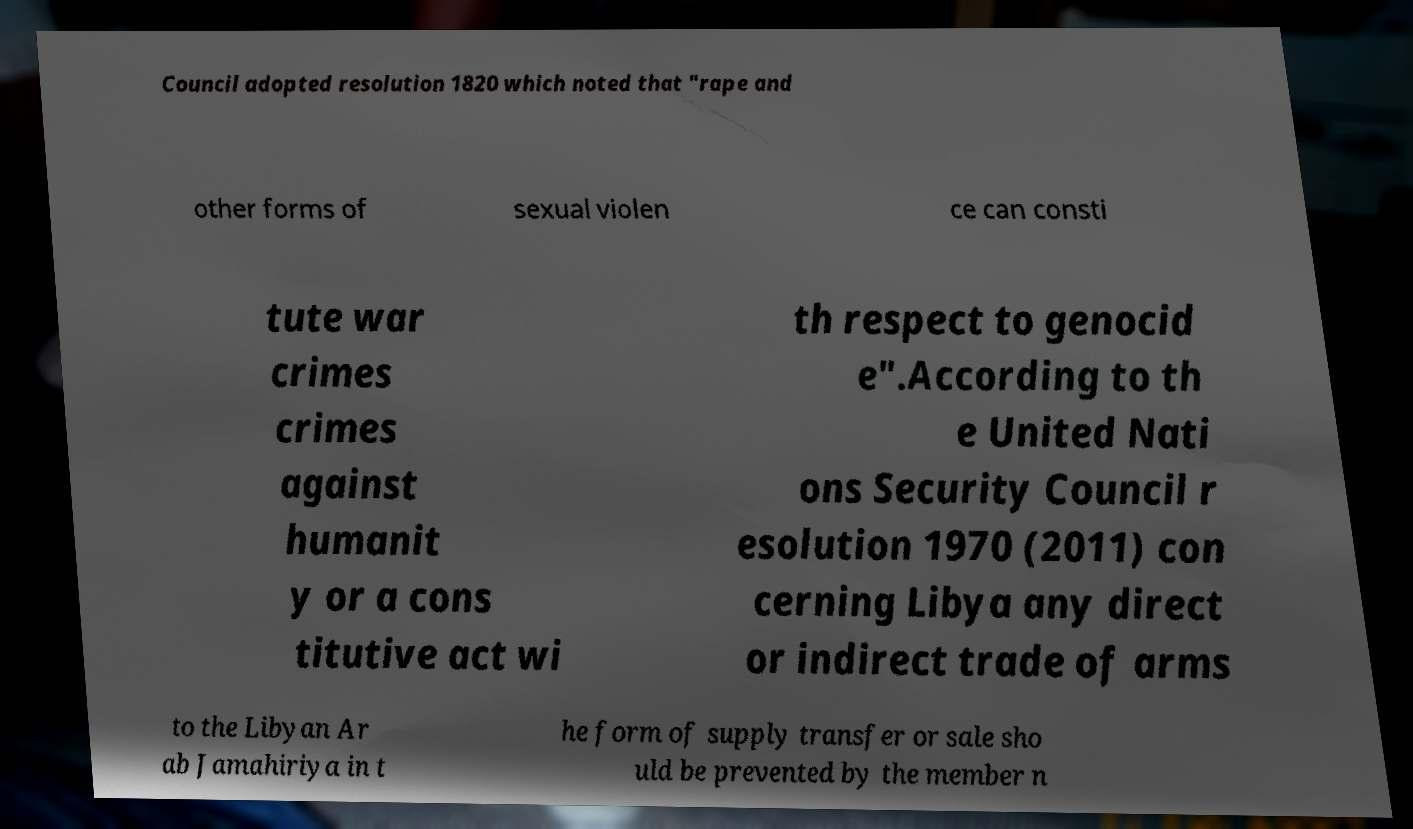Can you accurately transcribe the text from the provided image for me? Council adopted resolution 1820 which noted that "rape and other forms of sexual violen ce can consti tute war crimes crimes against humanit y or a cons titutive act wi th respect to genocid e".According to th e United Nati ons Security Council r esolution 1970 (2011) con cerning Libya any direct or indirect trade of arms to the Libyan Ar ab Jamahiriya in t he form of supply transfer or sale sho uld be prevented by the member n 